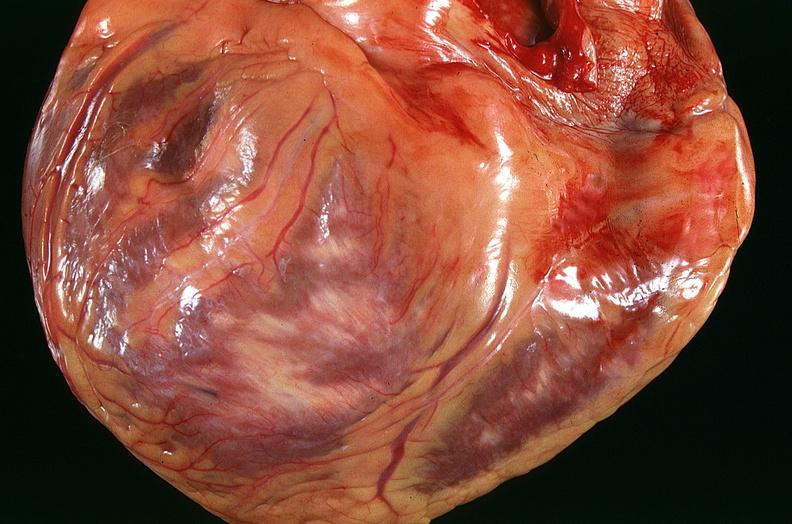where is this?
Answer the question using a single word or phrase. Heart 